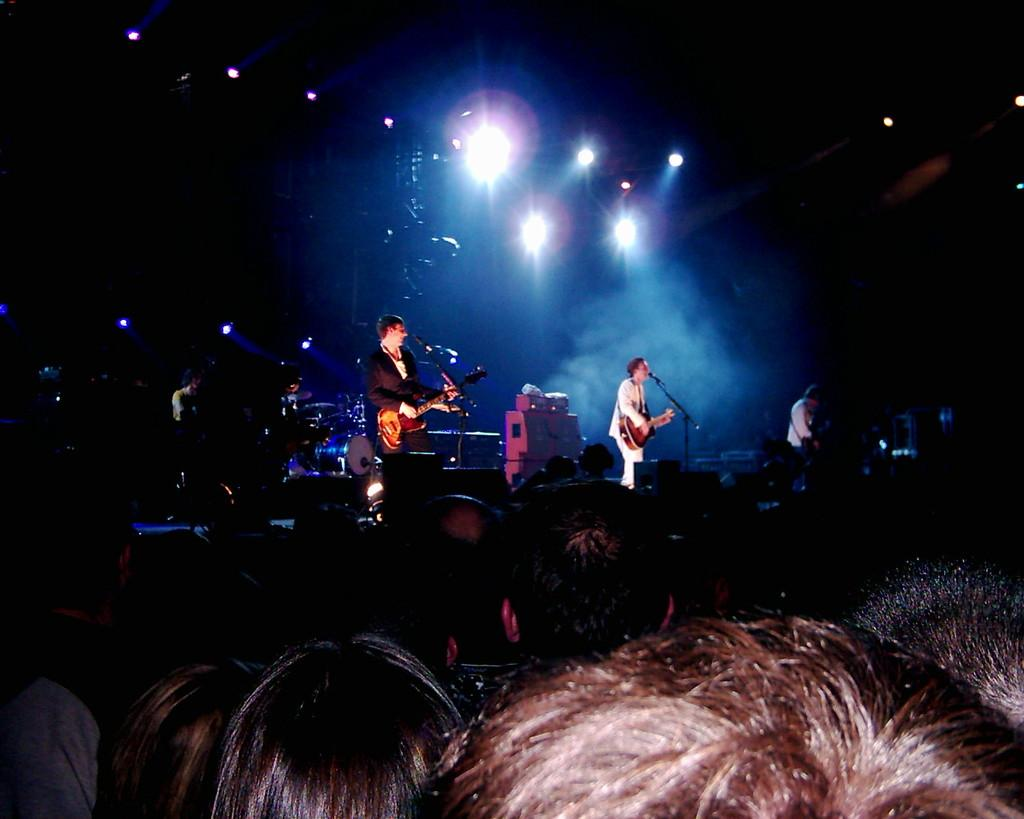What event is taking place in the image? There is a concert in the image. Who is performing at the concert? There are people on stage in the image, and they are playing musical instruments. Are there any spectators at the concert? Yes, there are people on the floor in the image, which suggests they are spectators. What can be seen in the image that might be used for illumination? There are lights visible in the image. What type of stew is being served to the audience during the concert? There is no mention of food or stew in the image; it focuses on the concert and the people performing on stage. What historical event is taking place during the concert? The image does not depict any historical event; it simply shows a concert with people on stage and spectators on the floor. 